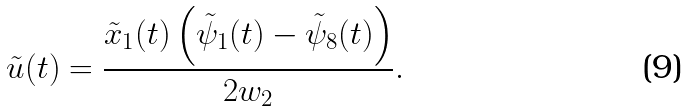<formula> <loc_0><loc_0><loc_500><loc_500>\tilde { u } ( t ) = \frac { \tilde { x } _ { 1 } ( t ) \left ( \tilde { \psi } _ { 1 } ( t ) - \tilde { \psi } _ { 8 } ( t ) \right ) } { 2 w _ { 2 } } .</formula> 